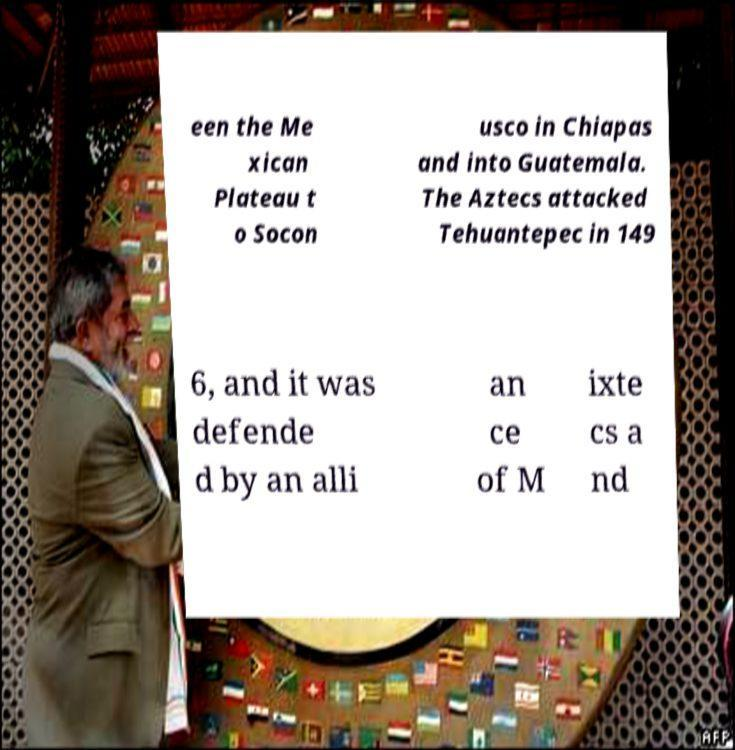Please read and relay the text visible in this image. What does it say? een the Me xican Plateau t o Socon usco in Chiapas and into Guatemala. The Aztecs attacked Tehuantepec in 149 6, and it was defende d by an alli an ce of M ixte cs a nd 